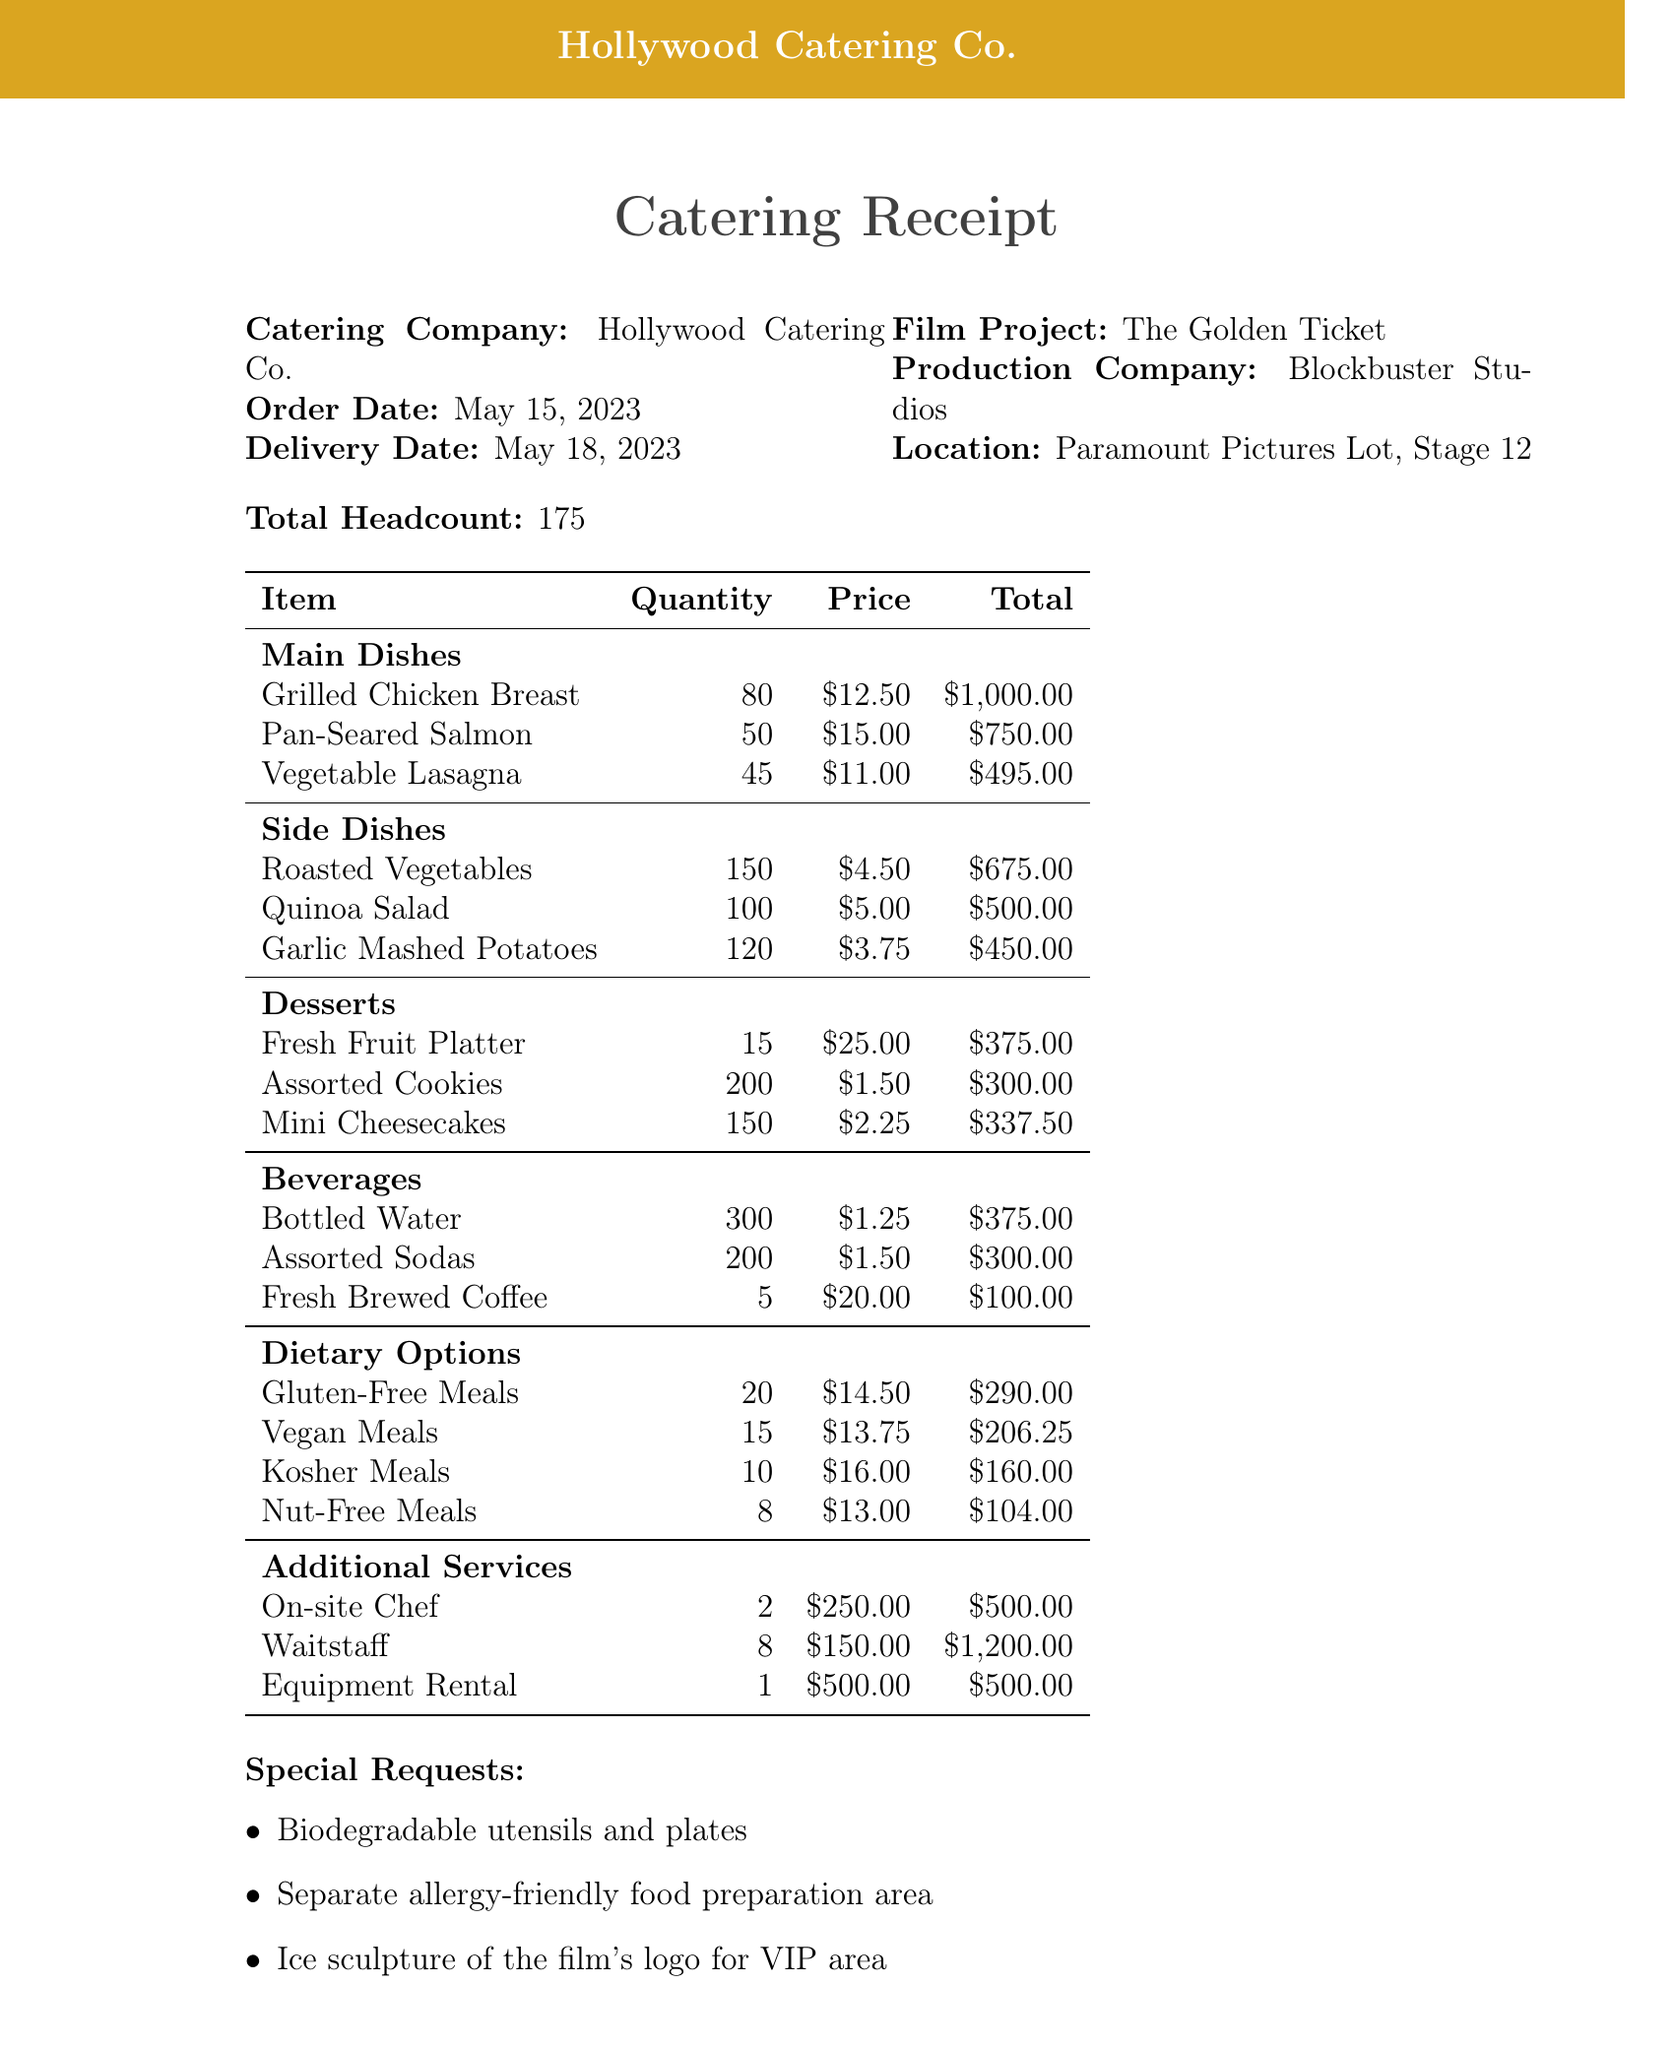What is the catering company? The name of the catering company is stated at the top of the receipt.
Answer: Hollywood Catering Co What is the order date? The order date is listed in the document under catering details.
Answer: May 15, 2023 What is the total headcount? The total number of people to be catered for is indicated in the document.
Answer: 175 How many Pan-Seared Salmon dishes were ordered? The quantity of Pan-Seared Salmon is specified under the main dishes section.
Answer: 50 What is the price of Gluten-Free Meals? The price for Gluten-Free Meals is given in the dietary options section.
Answer: 14.50 What percentage is the discount offered? The discount percentage is mentioned in the payment terms section of the document.
Answer: 5% What additional service has the highest cost? The additional service with the highest amount is listed at the end of the services section.
Answer: Waitstaff What is the tax rate applied? The tax rate is specified in the payment terms section of the receipt.
Answer: 9.5% What is the contact person's title? The title of the contact person is given in the contact section of the document.
Answer: Production Coordinator 